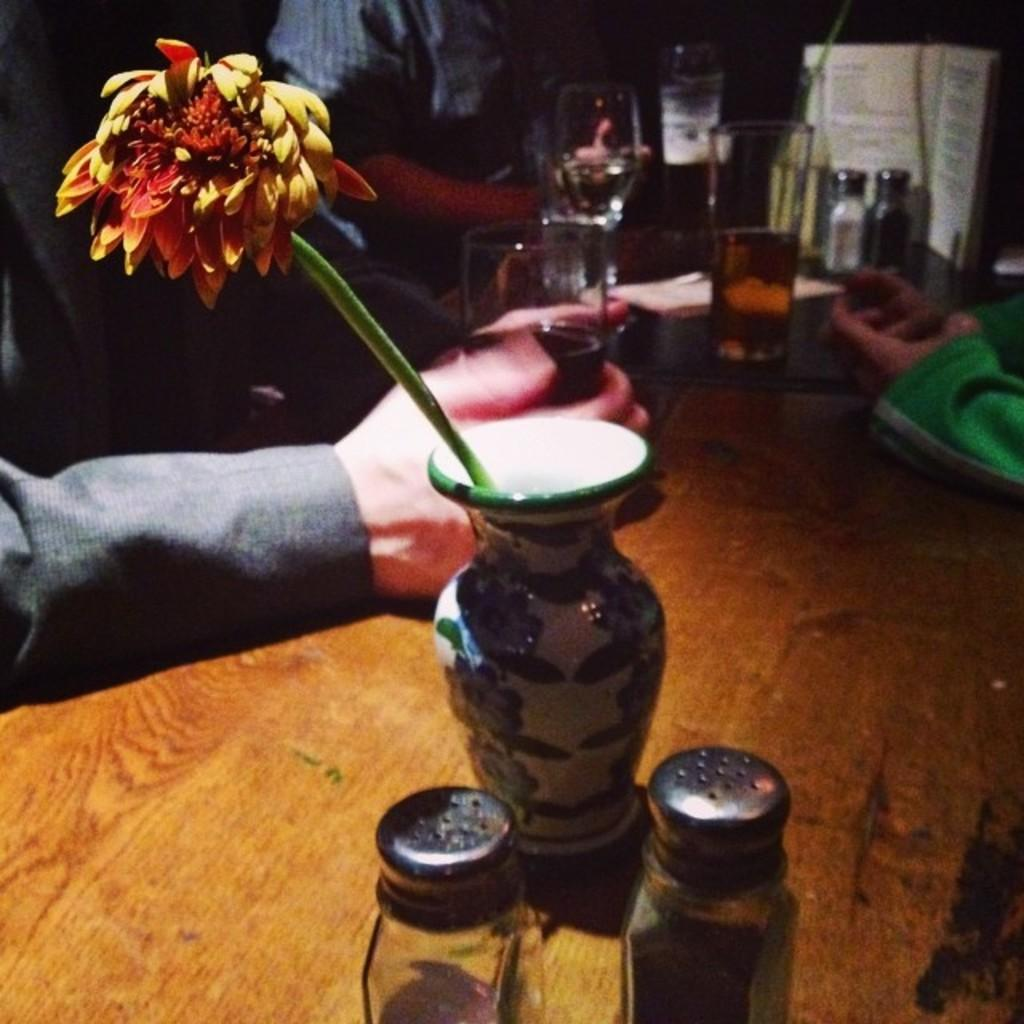What object can be seen in the image that is typically used for holding flowers? There is a flower vase in the image. What objects are on the table in the image? There are glasses on the table. What is the person in the image doing with a glass? A person is holding a glass in their hand. Can you see any flowers growing on the cobweb in the image? There is no cobweb or flowers present in the image. What type of event is taking place in the image? The image does not depict any specific event; it shows a flower vase, glasses, and a person holding a glass. 